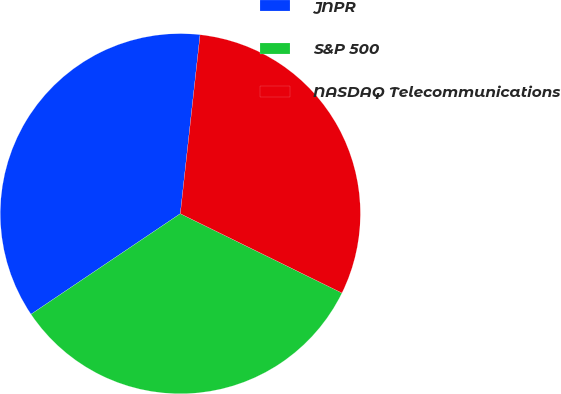<chart> <loc_0><loc_0><loc_500><loc_500><pie_chart><fcel>JNPR<fcel>S&P 500<fcel>NASDAQ Telecommunications<nl><fcel>36.18%<fcel>33.3%<fcel>30.51%<nl></chart> 